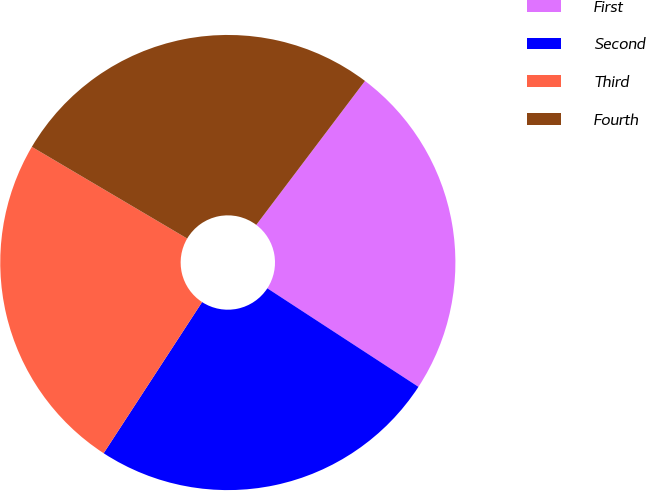Convert chart to OTSL. <chart><loc_0><loc_0><loc_500><loc_500><pie_chart><fcel>First<fcel>Second<fcel>Third<fcel>Fourth<nl><fcel>23.9%<fcel>24.99%<fcel>24.3%<fcel>26.81%<nl></chart> 